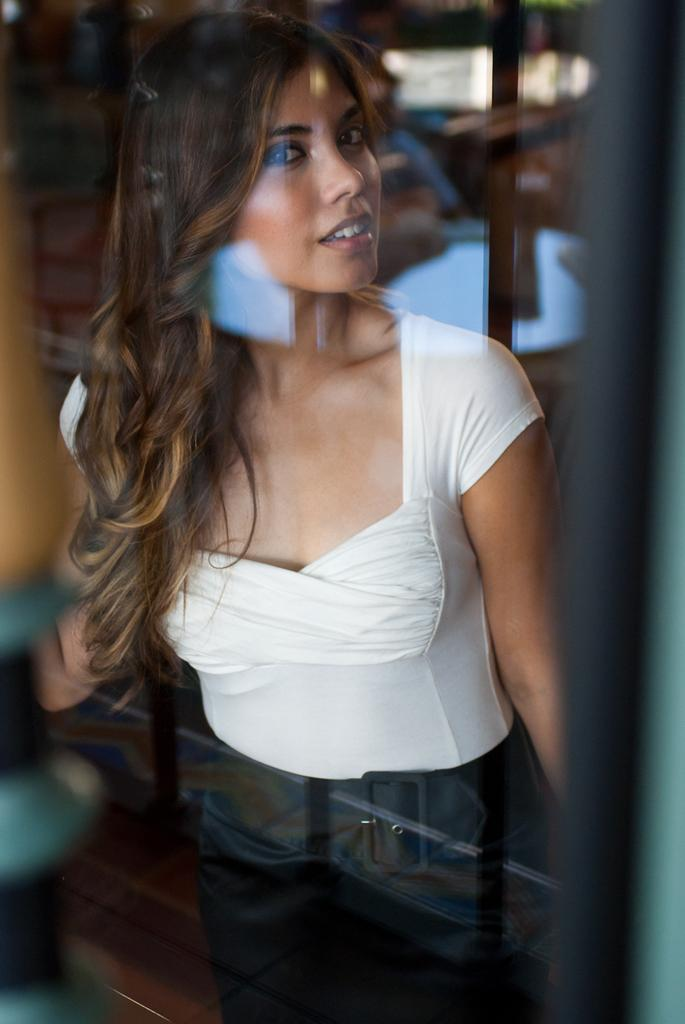What is the glass reflecting in the image? The glass has a reflection in the image. Who is present in the image? There is a woman standing in the image. What is the woman's expression in the image? The woman is smiling in the image. What color is the woman's top in the image? The woman is wearing a white top in the image. What type of bottom clothing is the woman wearing in the image? The woman is wearing trousers in the image. Can you see any mountains in the background of the image? There are no mountains visible in the image. Is the woman using a hose in the image? There is no hose present in the image. 